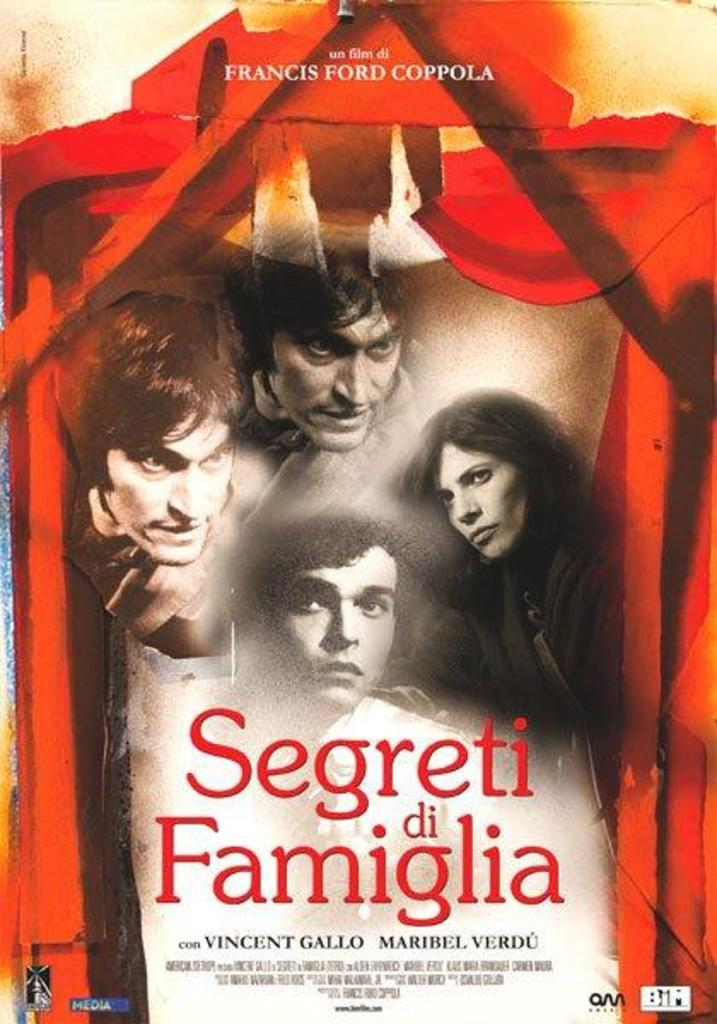<image>
Give a short and clear explanation of the subsequent image. A poster of Segreti di Famiglia shows the characters who play in it. 